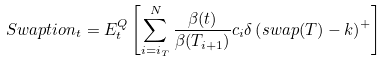Convert formula to latex. <formula><loc_0><loc_0><loc_500><loc_500>S w a p t i o n _ { t } = E _ { t } ^ { Q } \left [ \sum _ { i = i _ { T } } ^ { N } \frac { \beta ( t ) } { \beta ( T _ { i + 1 } ) } c _ { i } \delta \left ( s w a p ( T ) - k \right ) ^ { + } \right ]</formula> 